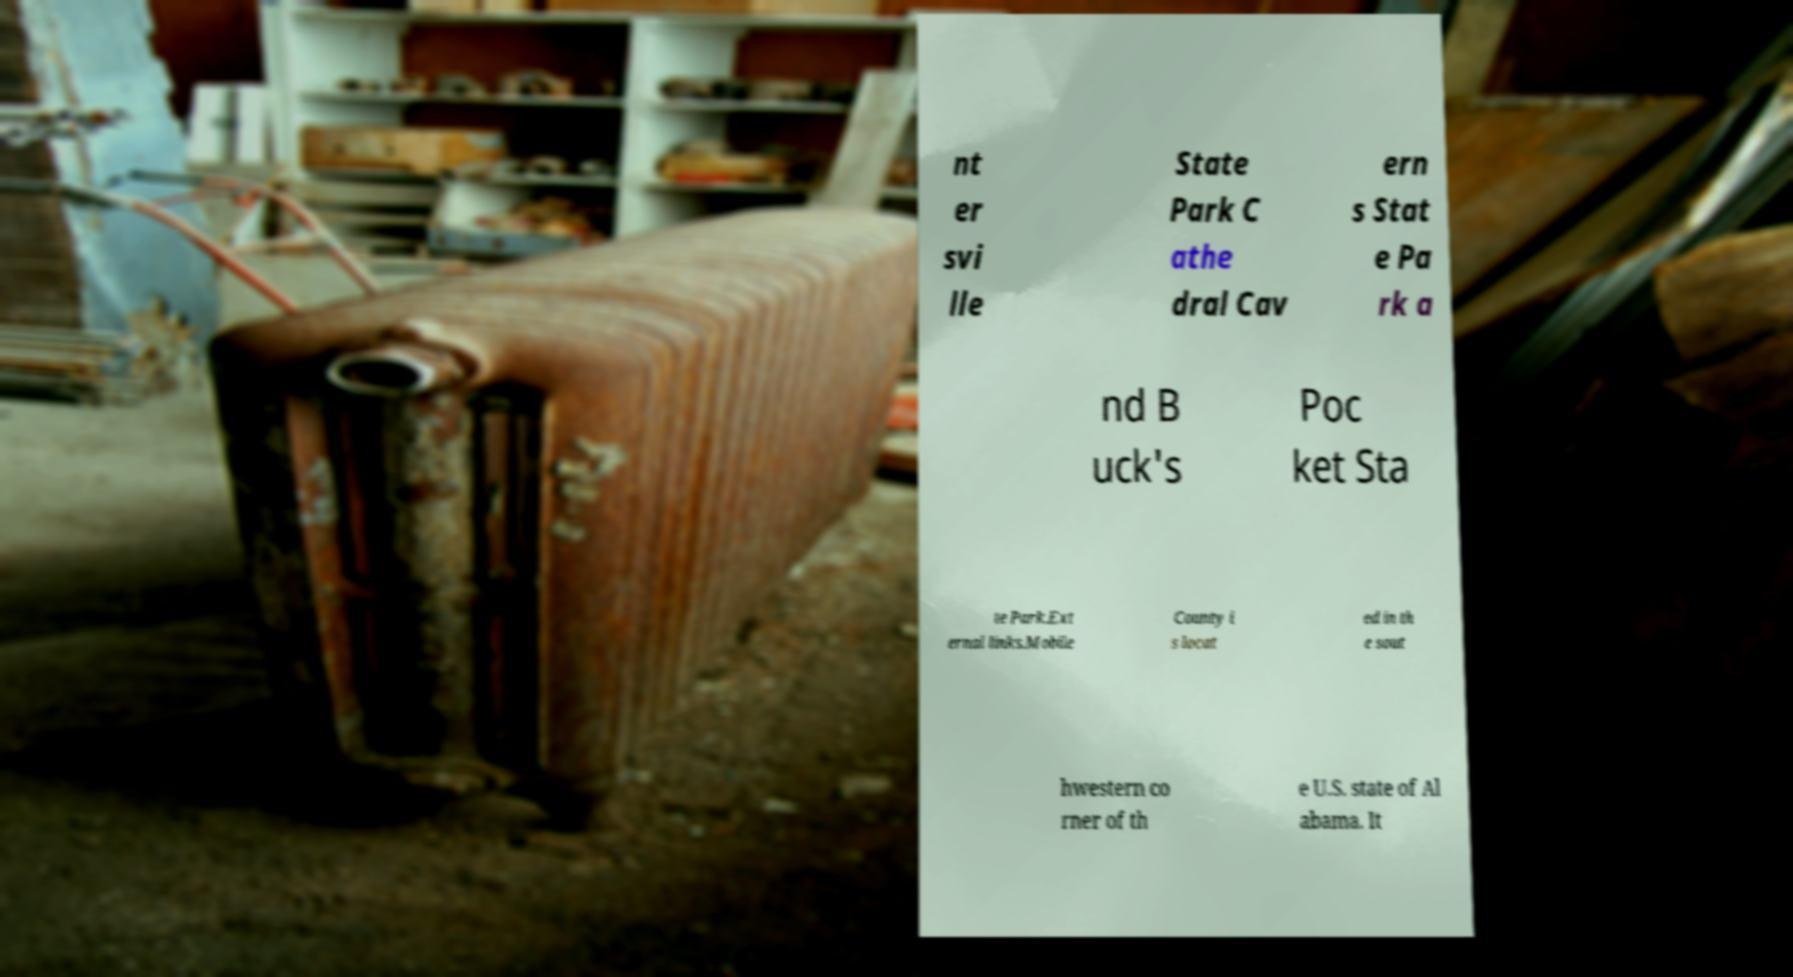What messages or text are displayed in this image? I need them in a readable, typed format. nt er svi lle State Park C athe dral Cav ern s Stat e Pa rk a nd B uck's Poc ket Sta te Park.Ext ernal links.Mobile County i s locat ed in th e sout hwestern co rner of th e U.S. state of Al abama. It 